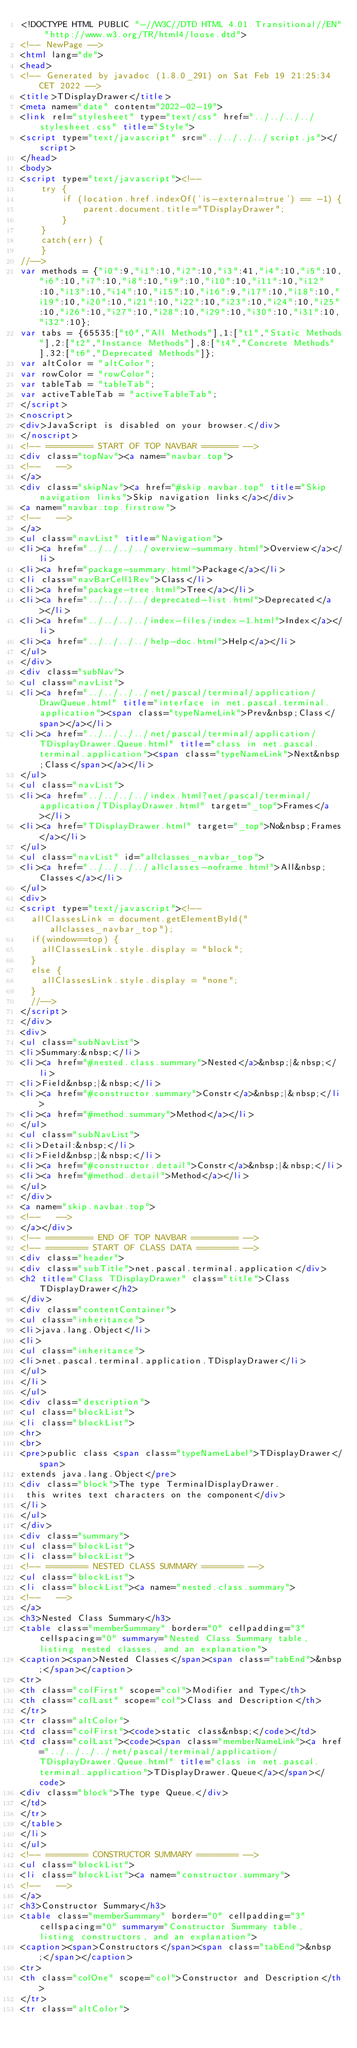Convert code to text. <code><loc_0><loc_0><loc_500><loc_500><_HTML_><!DOCTYPE HTML PUBLIC "-//W3C//DTD HTML 4.01 Transitional//EN" "http://www.w3.org/TR/html4/loose.dtd">
<!-- NewPage -->
<html lang="de">
<head>
<!-- Generated by javadoc (1.8.0_291) on Sat Feb 19 21:25:34 CET 2022 -->
<title>TDisplayDrawer</title>
<meta name="date" content="2022-02-19">
<link rel="stylesheet" type="text/css" href="../../../../stylesheet.css" title="Style">
<script type="text/javascript" src="../../../../script.js"></script>
</head>
<body>
<script type="text/javascript"><!--
    try {
        if (location.href.indexOf('is-external=true') == -1) {
            parent.document.title="TDisplayDrawer";
        }
    }
    catch(err) {
    }
//-->
var methods = {"i0":9,"i1":10,"i2":10,"i3":41,"i4":10,"i5":10,"i6":10,"i7":10,"i8":10,"i9":10,"i10":10,"i11":10,"i12":10,"i13":10,"i14":10,"i15":10,"i16":9,"i17":10,"i18":10,"i19":10,"i20":10,"i21":10,"i22":10,"i23":10,"i24":10,"i25":10,"i26":10,"i27":10,"i28":10,"i29":10,"i30":10,"i31":10,"i32":10};
var tabs = {65535:["t0","All Methods"],1:["t1","Static Methods"],2:["t2","Instance Methods"],8:["t4","Concrete Methods"],32:["t6","Deprecated Methods"]};
var altColor = "altColor";
var rowColor = "rowColor";
var tableTab = "tableTab";
var activeTableTab = "activeTableTab";
</script>
<noscript>
<div>JavaScript is disabled on your browser.</div>
</noscript>
<!-- ========= START OF TOP NAVBAR ======= -->
<div class="topNav"><a name="navbar.top">
<!--   -->
</a>
<div class="skipNav"><a href="#skip.navbar.top" title="Skip navigation links">Skip navigation links</a></div>
<a name="navbar.top.firstrow">
<!--   -->
</a>
<ul class="navList" title="Navigation">
<li><a href="../../../../overview-summary.html">Overview</a></li>
<li><a href="package-summary.html">Package</a></li>
<li class="navBarCell1Rev">Class</li>
<li><a href="package-tree.html">Tree</a></li>
<li><a href="../../../../deprecated-list.html">Deprecated</a></li>
<li><a href="../../../../index-files/index-1.html">Index</a></li>
<li><a href="../../../../help-doc.html">Help</a></li>
</ul>
</div>
<div class="subNav">
<ul class="navList">
<li><a href="../../../../net/pascal/terminal/application/DrawQueue.html" title="interface in net.pascal.terminal.application"><span class="typeNameLink">Prev&nbsp;Class</span></a></li>
<li><a href="../../../../net/pascal/terminal/application/TDisplayDrawer.Queue.html" title="class in net.pascal.terminal.application"><span class="typeNameLink">Next&nbsp;Class</span></a></li>
</ul>
<ul class="navList">
<li><a href="../../../../index.html?net/pascal/terminal/application/TDisplayDrawer.html" target="_top">Frames</a></li>
<li><a href="TDisplayDrawer.html" target="_top">No&nbsp;Frames</a></li>
</ul>
<ul class="navList" id="allclasses_navbar_top">
<li><a href="../../../../allclasses-noframe.html">All&nbsp;Classes</a></li>
</ul>
<div>
<script type="text/javascript"><!--
  allClassesLink = document.getElementById("allclasses_navbar_top");
  if(window==top) {
    allClassesLink.style.display = "block";
  }
  else {
    allClassesLink.style.display = "none";
  }
  //-->
</script>
</div>
<div>
<ul class="subNavList">
<li>Summary:&nbsp;</li>
<li><a href="#nested.class.summary">Nested</a>&nbsp;|&nbsp;</li>
<li>Field&nbsp;|&nbsp;</li>
<li><a href="#constructor.summary">Constr</a>&nbsp;|&nbsp;</li>
<li><a href="#method.summary">Method</a></li>
</ul>
<ul class="subNavList">
<li>Detail:&nbsp;</li>
<li>Field&nbsp;|&nbsp;</li>
<li><a href="#constructor.detail">Constr</a>&nbsp;|&nbsp;</li>
<li><a href="#method.detail">Method</a></li>
</ul>
</div>
<a name="skip.navbar.top">
<!--   -->
</a></div>
<!-- ========= END OF TOP NAVBAR ========= -->
<!-- ======== START OF CLASS DATA ======== -->
<div class="header">
<div class="subTitle">net.pascal.terminal.application</div>
<h2 title="Class TDisplayDrawer" class="title">Class TDisplayDrawer</h2>
</div>
<div class="contentContainer">
<ul class="inheritance">
<li>java.lang.Object</li>
<li>
<ul class="inheritance">
<li>net.pascal.terminal.application.TDisplayDrawer</li>
</ul>
</li>
</ul>
<div class="description">
<ul class="blockList">
<li class="blockList">
<hr>
<br>
<pre>public class <span class="typeNameLabel">TDisplayDrawer</span>
extends java.lang.Object</pre>
<div class="block">The type TerminalDisplayDrawer.
 this writes text characters on the component</div>
</li>
</ul>
</div>
<div class="summary">
<ul class="blockList">
<li class="blockList">
<!-- ======== NESTED CLASS SUMMARY ======== -->
<ul class="blockList">
<li class="blockList"><a name="nested.class.summary">
<!--   -->
</a>
<h3>Nested Class Summary</h3>
<table class="memberSummary" border="0" cellpadding="3" cellspacing="0" summary="Nested Class Summary table, listing nested classes, and an explanation">
<caption><span>Nested Classes</span><span class="tabEnd">&nbsp;</span></caption>
<tr>
<th class="colFirst" scope="col">Modifier and Type</th>
<th class="colLast" scope="col">Class and Description</th>
</tr>
<tr class="altColor">
<td class="colFirst"><code>static class&nbsp;</code></td>
<td class="colLast"><code><span class="memberNameLink"><a href="../../../../net/pascal/terminal/application/TDisplayDrawer.Queue.html" title="class in net.pascal.terminal.application">TDisplayDrawer.Queue</a></span></code>
<div class="block">The type Queue.</div>
</td>
</tr>
</table>
</li>
</ul>
<!-- ======== CONSTRUCTOR SUMMARY ======== -->
<ul class="blockList">
<li class="blockList"><a name="constructor.summary">
<!--   -->
</a>
<h3>Constructor Summary</h3>
<table class="memberSummary" border="0" cellpadding="3" cellspacing="0" summary="Constructor Summary table, listing constructors, and an explanation">
<caption><span>Constructors</span><span class="tabEnd">&nbsp;</span></caption>
<tr>
<th class="colOne" scope="col">Constructor and Description</th>
</tr>
<tr class="altColor"></code> 